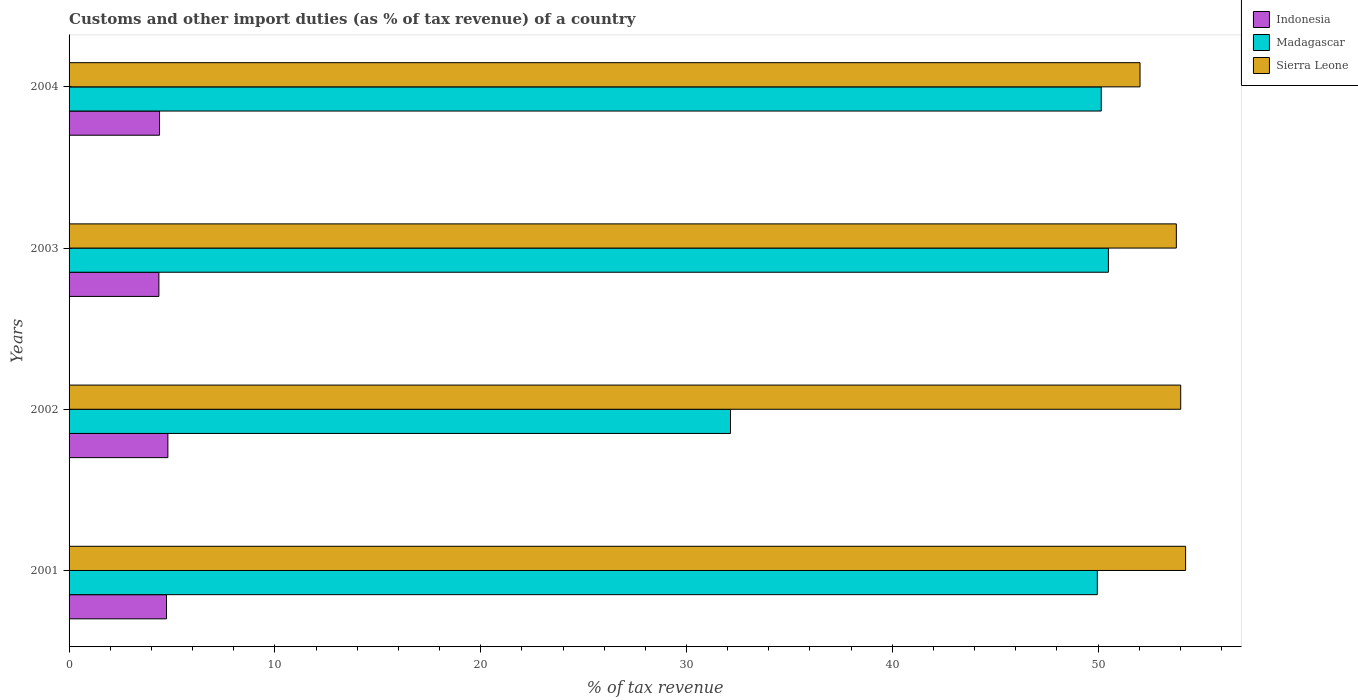Are the number of bars per tick equal to the number of legend labels?
Make the answer very short. Yes. Are the number of bars on each tick of the Y-axis equal?
Provide a succinct answer. Yes. What is the label of the 2nd group of bars from the top?
Keep it short and to the point. 2003. In how many cases, is the number of bars for a given year not equal to the number of legend labels?
Your answer should be very brief. 0. What is the percentage of tax revenue from customs in Madagascar in 2001?
Your answer should be very brief. 49.96. Across all years, what is the maximum percentage of tax revenue from customs in Madagascar?
Make the answer very short. 50.5. Across all years, what is the minimum percentage of tax revenue from customs in Sierra Leone?
Provide a succinct answer. 52.04. What is the total percentage of tax revenue from customs in Sierra Leone in the graph?
Provide a succinct answer. 214.1. What is the difference between the percentage of tax revenue from customs in Indonesia in 2002 and that in 2003?
Give a very brief answer. 0.44. What is the difference between the percentage of tax revenue from customs in Indonesia in 2003 and the percentage of tax revenue from customs in Sierra Leone in 2002?
Provide a succinct answer. -49.65. What is the average percentage of tax revenue from customs in Madagascar per year?
Give a very brief answer. 45.69. In the year 2001, what is the difference between the percentage of tax revenue from customs in Indonesia and percentage of tax revenue from customs in Sierra Leone?
Ensure brevity in your answer.  -49.52. In how many years, is the percentage of tax revenue from customs in Madagascar greater than 4 %?
Provide a succinct answer. 4. What is the ratio of the percentage of tax revenue from customs in Madagascar in 2003 to that in 2004?
Offer a very short reply. 1.01. What is the difference between the highest and the second highest percentage of tax revenue from customs in Sierra Leone?
Give a very brief answer. 0.24. What is the difference between the highest and the lowest percentage of tax revenue from customs in Sierra Leone?
Provide a short and direct response. 2.21. What does the 1st bar from the top in 2001 represents?
Keep it short and to the point. Sierra Leone. What does the 3rd bar from the bottom in 2001 represents?
Offer a terse response. Sierra Leone. How many years are there in the graph?
Your response must be concise. 4. Are the values on the major ticks of X-axis written in scientific E-notation?
Give a very brief answer. No. Where does the legend appear in the graph?
Ensure brevity in your answer.  Top right. How are the legend labels stacked?
Offer a very short reply. Vertical. What is the title of the graph?
Offer a terse response. Customs and other import duties (as % of tax revenue) of a country. What is the label or title of the X-axis?
Your answer should be compact. % of tax revenue. What is the label or title of the Y-axis?
Offer a very short reply. Years. What is the % of tax revenue of Indonesia in 2001?
Your response must be concise. 4.74. What is the % of tax revenue in Madagascar in 2001?
Keep it short and to the point. 49.96. What is the % of tax revenue of Sierra Leone in 2001?
Make the answer very short. 54.25. What is the % of tax revenue of Indonesia in 2002?
Give a very brief answer. 4.8. What is the % of tax revenue in Madagascar in 2002?
Make the answer very short. 32.14. What is the % of tax revenue in Sierra Leone in 2002?
Make the answer very short. 54.01. What is the % of tax revenue of Indonesia in 2003?
Give a very brief answer. 4.36. What is the % of tax revenue of Madagascar in 2003?
Ensure brevity in your answer.  50.5. What is the % of tax revenue in Sierra Leone in 2003?
Offer a very short reply. 53.8. What is the % of tax revenue in Indonesia in 2004?
Ensure brevity in your answer.  4.4. What is the % of tax revenue in Madagascar in 2004?
Offer a terse response. 50.15. What is the % of tax revenue of Sierra Leone in 2004?
Offer a terse response. 52.04. Across all years, what is the maximum % of tax revenue of Indonesia?
Offer a terse response. 4.8. Across all years, what is the maximum % of tax revenue in Madagascar?
Provide a short and direct response. 50.5. Across all years, what is the maximum % of tax revenue of Sierra Leone?
Provide a short and direct response. 54.25. Across all years, what is the minimum % of tax revenue in Indonesia?
Your answer should be compact. 4.36. Across all years, what is the minimum % of tax revenue in Madagascar?
Your answer should be compact. 32.14. Across all years, what is the minimum % of tax revenue in Sierra Leone?
Offer a very short reply. 52.04. What is the total % of tax revenue in Indonesia in the graph?
Your answer should be very brief. 18.3. What is the total % of tax revenue in Madagascar in the graph?
Your answer should be compact. 182.75. What is the total % of tax revenue of Sierra Leone in the graph?
Keep it short and to the point. 214.1. What is the difference between the % of tax revenue in Indonesia in 2001 and that in 2002?
Provide a short and direct response. -0.07. What is the difference between the % of tax revenue of Madagascar in 2001 and that in 2002?
Your response must be concise. 17.82. What is the difference between the % of tax revenue in Sierra Leone in 2001 and that in 2002?
Provide a succinct answer. 0.24. What is the difference between the % of tax revenue in Indonesia in 2001 and that in 2003?
Keep it short and to the point. 0.37. What is the difference between the % of tax revenue in Madagascar in 2001 and that in 2003?
Your answer should be very brief. -0.54. What is the difference between the % of tax revenue in Sierra Leone in 2001 and that in 2003?
Your response must be concise. 0.45. What is the difference between the % of tax revenue of Indonesia in 2001 and that in 2004?
Provide a short and direct response. 0.34. What is the difference between the % of tax revenue in Madagascar in 2001 and that in 2004?
Make the answer very short. -0.19. What is the difference between the % of tax revenue in Sierra Leone in 2001 and that in 2004?
Your answer should be compact. 2.21. What is the difference between the % of tax revenue of Indonesia in 2002 and that in 2003?
Ensure brevity in your answer.  0.44. What is the difference between the % of tax revenue in Madagascar in 2002 and that in 2003?
Ensure brevity in your answer.  -18.36. What is the difference between the % of tax revenue in Sierra Leone in 2002 and that in 2003?
Offer a terse response. 0.21. What is the difference between the % of tax revenue in Indonesia in 2002 and that in 2004?
Offer a very short reply. 0.41. What is the difference between the % of tax revenue in Madagascar in 2002 and that in 2004?
Offer a very short reply. -18.01. What is the difference between the % of tax revenue of Sierra Leone in 2002 and that in 2004?
Your response must be concise. 1.98. What is the difference between the % of tax revenue of Indonesia in 2003 and that in 2004?
Your answer should be very brief. -0.03. What is the difference between the % of tax revenue in Madagascar in 2003 and that in 2004?
Your answer should be compact. 0.35. What is the difference between the % of tax revenue in Sierra Leone in 2003 and that in 2004?
Offer a very short reply. 1.76. What is the difference between the % of tax revenue of Indonesia in 2001 and the % of tax revenue of Madagascar in 2002?
Make the answer very short. -27.4. What is the difference between the % of tax revenue in Indonesia in 2001 and the % of tax revenue in Sierra Leone in 2002?
Give a very brief answer. -49.28. What is the difference between the % of tax revenue in Madagascar in 2001 and the % of tax revenue in Sierra Leone in 2002?
Your response must be concise. -4.05. What is the difference between the % of tax revenue in Indonesia in 2001 and the % of tax revenue in Madagascar in 2003?
Provide a short and direct response. -45.77. What is the difference between the % of tax revenue in Indonesia in 2001 and the % of tax revenue in Sierra Leone in 2003?
Make the answer very short. -49.07. What is the difference between the % of tax revenue in Madagascar in 2001 and the % of tax revenue in Sierra Leone in 2003?
Ensure brevity in your answer.  -3.84. What is the difference between the % of tax revenue in Indonesia in 2001 and the % of tax revenue in Madagascar in 2004?
Provide a succinct answer. -45.42. What is the difference between the % of tax revenue in Indonesia in 2001 and the % of tax revenue in Sierra Leone in 2004?
Ensure brevity in your answer.  -47.3. What is the difference between the % of tax revenue of Madagascar in 2001 and the % of tax revenue of Sierra Leone in 2004?
Give a very brief answer. -2.07. What is the difference between the % of tax revenue of Indonesia in 2002 and the % of tax revenue of Madagascar in 2003?
Your response must be concise. -45.7. What is the difference between the % of tax revenue of Indonesia in 2002 and the % of tax revenue of Sierra Leone in 2003?
Your response must be concise. -49. What is the difference between the % of tax revenue in Madagascar in 2002 and the % of tax revenue in Sierra Leone in 2003?
Make the answer very short. -21.66. What is the difference between the % of tax revenue of Indonesia in 2002 and the % of tax revenue of Madagascar in 2004?
Provide a succinct answer. -45.35. What is the difference between the % of tax revenue of Indonesia in 2002 and the % of tax revenue of Sierra Leone in 2004?
Keep it short and to the point. -47.24. What is the difference between the % of tax revenue of Madagascar in 2002 and the % of tax revenue of Sierra Leone in 2004?
Provide a succinct answer. -19.9. What is the difference between the % of tax revenue in Indonesia in 2003 and the % of tax revenue in Madagascar in 2004?
Ensure brevity in your answer.  -45.79. What is the difference between the % of tax revenue of Indonesia in 2003 and the % of tax revenue of Sierra Leone in 2004?
Provide a succinct answer. -47.67. What is the difference between the % of tax revenue of Madagascar in 2003 and the % of tax revenue of Sierra Leone in 2004?
Keep it short and to the point. -1.54. What is the average % of tax revenue of Indonesia per year?
Provide a short and direct response. 4.57. What is the average % of tax revenue of Madagascar per year?
Your answer should be very brief. 45.69. What is the average % of tax revenue of Sierra Leone per year?
Offer a very short reply. 53.53. In the year 2001, what is the difference between the % of tax revenue of Indonesia and % of tax revenue of Madagascar?
Your response must be concise. -45.23. In the year 2001, what is the difference between the % of tax revenue in Indonesia and % of tax revenue in Sierra Leone?
Keep it short and to the point. -49.52. In the year 2001, what is the difference between the % of tax revenue in Madagascar and % of tax revenue in Sierra Leone?
Your response must be concise. -4.29. In the year 2002, what is the difference between the % of tax revenue of Indonesia and % of tax revenue of Madagascar?
Keep it short and to the point. -27.34. In the year 2002, what is the difference between the % of tax revenue in Indonesia and % of tax revenue in Sierra Leone?
Your answer should be very brief. -49.21. In the year 2002, what is the difference between the % of tax revenue in Madagascar and % of tax revenue in Sierra Leone?
Your answer should be compact. -21.87. In the year 2003, what is the difference between the % of tax revenue in Indonesia and % of tax revenue in Madagascar?
Provide a succinct answer. -46.14. In the year 2003, what is the difference between the % of tax revenue of Indonesia and % of tax revenue of Sierra Leone?
Your answer should be compact. -49.44. In the year 2003, what is the difference between the % of tax revenue in Madagascar and % of tax revenue in Sierra Leone?
Give a very brief answer. -3.3. In the year 2004, what is the difference between the % of tax revenue in Indonesia and % of tax revenue in Madagascar?
Give a very brief answer. -45.76. In the year 2004, what is the difference between the % of tax revenue in Indonesia and % of tax revenue in Sierra Leone?
Ensure brevity in your answer.  -47.64. In the year 2004, what is the difference between the % of tax revenue of Madagascar and % of tax revenue of Sierra Leone?
Offer a terse response. -1.88. What is the ratio of the % of tax revenue in Indonesia in 2001 to that in 2002?
Your answer should be very brief. 0.99. What is the ratio of the % of tax revenue of Madagascar in 2001 to that in 2002?
Provide a short and direct response. 1.55. What is the ratio of the % of tax revenue in Sierra Leone in 2001 to that in 2002?
Provide a short and direct response. 1. What is the ratio of the % of tax revenue in Indonesia in 2001 to that in 2003?
Your response must be concise. 1.08. What is the ratio of the % of tax revenue of Madagascar in 2001 to that in 2003?
Your response must be concise. 0.99. What is the ratio of the % of tax revenue of Sierra Leone in 2001 to that in 2003?
Provide a succinct answer. 1.01. What is the ratio of the % of tax revenue of Indonesia in 2001 to that in 2004?
Ensure brevity in your answer.  1.08. What is the ratio of the % of tax revenue in Madagascar in 2001 to that in 2004?
Give a very brief answer. 1. What is the ratio of the % of tax revenue in Sierra Leone in 2001 to that in 2004?
Keep it short and to the point. 1.04. What is the ratio of the % of tax revenue in Indonesia in 2002 to that in 2003?
Make the answer very short. 1.1. What is the ratio of the % of tax revenue in Madagascar in 2002 to that in 2003?
Offer a very short reply. 0.64. What is the ratio of the % of tax revenue of Indonesia in 2002 to that in 2004?
Ensure brevity in your answer.  1.09. What is the ratio of the % of tax revenue in Madagascar in 2002 to that in 2004?
Provide a succinct answer. 0.64. What is the ratio of the % of tax revenue in Sierra Leone in 2002 to that in 2004?
Your response must be concise. 1.04. What is the ratio of the % of tax revenue of Madagascar in 2003 to that in 2004?
Give a very brief answer. 1.01. What is the ratio of the % of tax revenue in Sierra Leone in 2003 to that in 2004?
Your response must be concise. 1.03. What is the difference between the highest and the second highest % of tax revenue of Indonesia?
Keep it short and to the point. 0.07. What is the difference between the highest and the second highest % of tax revenue of Madagascar?
Provide a short and direct response. 0.35. What is the difference between the highest and the second highest % of tax revenue in Sierra Leone?
Give a very brief answer. 0.24. What is the difference between the highest and the lowest % of tax revenue of Indonesia?
Make the answer very short. 0.44. What is the difference between the highest and the lowest % of tax revenue in Madagascar?
Provide a succinct answer. 18.36. What is the difference between the highest and the lowest % of tax revenue in Sierra Leone?
Make the answer very short. 2.21. 